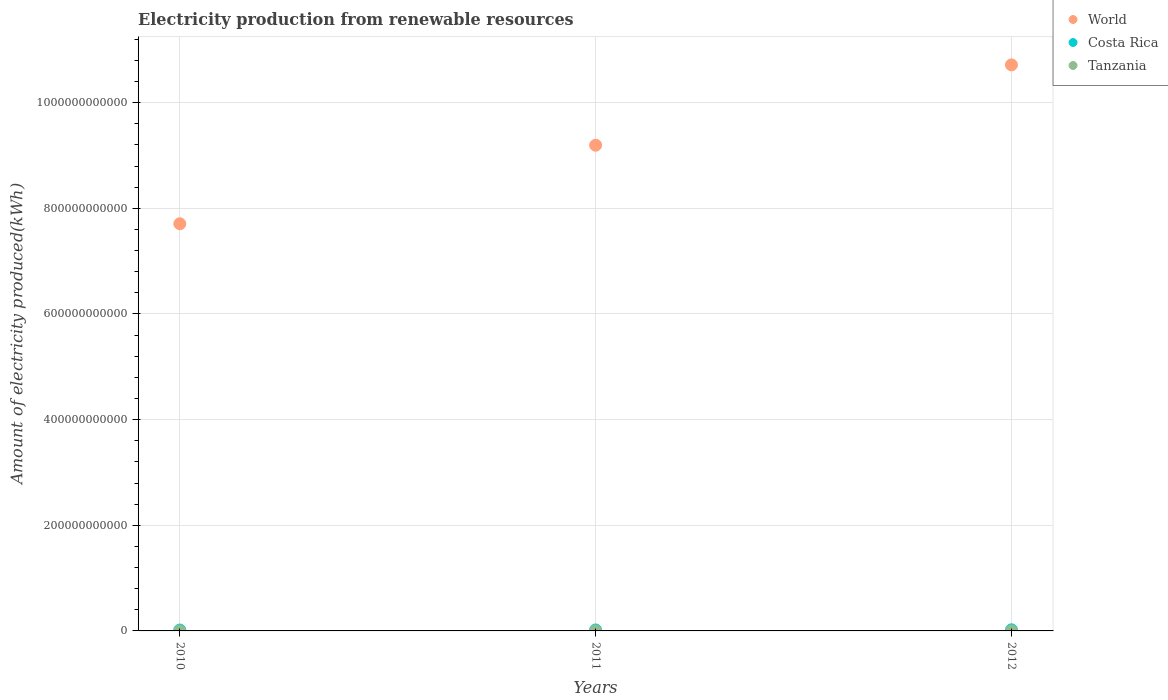How many different coloured dotlines are there?
Give a very brief answer. 3. Is the number of dotlines equal to the number of legend labels?
Give a very brief answer. Yes. What is the amount of electricity produced in World in 2012?
Keep it short and to the point. 1.07e+12. Across all years, what is the maximum amount of electricity produced in Tanzania?
Offer a very short reply. 3.20e+07. Across all years, what is the minimum amount of electricity produced in Costa Rica?
Ensure brevity in your answer.  1.68e+09. In which year was the amount of electricity produced in Costa Rica minimum?
Ensure brevity in your answer.  2010. What is the total amount of electricity produced in World in the graph?
Ensure brevity in your answer.  2.76e+12. What is the difference between the amount of electricity produced in Tanzania in 2010 and that in 2012?
Your answer should be very brief. -1.40e+07. What is the difference between the amount of electricity produced in Costa Rica in 2010 and the amount of electricity produced in World in 2012?
Provide a short and direct response. -1.07e+12. What is the average amount of electricity produced in Costa Rica per year?
Keep it short and to the point. 1.88e+09. In the year 2011, what is the difference between the amount of electricity produced in Tanzania and amount of electricity produced in Costa Rica?
Offer a very short reply. -1.81e+09. What is the ratio of the amount of electricity produced in Tanzania in 2011 to that in 2012?
Your response must be concise. 0.78. Is the amount of electricity produced in Tanzania in 2011 less than that in 2012?
Your answer should be very brief. Yes. What is the difference between the highest and the second highest amount of electricity produced in Costa Rica?
Give a very brief answer. 2.76e+08. What is the difference between the highest and the lowest amount of electricity produced in World?
Your response must be concise. 3.01e+11. Is it the case that in every year, the sum of the amount of electricity produced in World and amount of electricity produced in Costa Rica  is greater than the amount of electricity produced in Tanzania?
Keep it short and to the point. Yes. Does the amount of electricity produced in World monotonically increase over the years?
Provide a short and direct response. Yes. Is the amount of electricity produced in World strictly less than the amount of electricity produced in Costa Rica over the years?
Offer a very short reply. No. How many dotlines are there?
Your answer should be very brief. 3. How many years are there in the graph?
Offer a very short reply. 3. What is the difference between two consecutive major ticks on the Y-axis?
Provide a short and direct response. 2.00e+11. Where does the legend appear in the graph?
Your answer should be compact. Top right. How many legend labels are there?
Offer a terse response. 3. How are the legend labels stacked?
Ensure brevity in your answer.  Vertical. What is the title of the graph?
Provide a succinct answer. Electricity production from renewable resources. What is the label or title of the X-axis?
Your answer should be compact. Years. What is the label or title of the Y-axis?
Keep it short and to the point. Amount of electricity produced(kWh). What is the Amount of electricity produced(kWh) of World in 2010?
Give a very brief answer. 7.71e+11. What is the Amount of electricity produced(kWh) in Costa Rica in 2010?
Provide a short and direct response. 1.68e+09. What is the Amount of electricity produced(kWh) in Tanzania in 2010?
Your response must be concise. 1.80e+07. What is the Amount of electricity produced(kWh) in World in 2011?
Your response must be concise. 9.20e+11. What is the Amount of electricity produced(kWh) of Costa Rica in 2011?
Provide a short and direct response. 1.84e+09. What is the Amount of electricity produced(kWh) of Tanzania in 2011?
Offer a terse response. 2.50e+07. What is the Amount of electricity produced(kWh) of World in 2012?
Provide a short and direct response. 1.07e+12. What is the Amount of electricity produced(kWh) of Costa Rica in 2012?
Your response must be concise. 2.11e+09. What is the Amount of electricity produced(kWh) in Tanzania in 2012?
Offer a very short reply. 3.20e+07. Across all years, what is the maximum Amount of electricity produced(kWh) of World?
Provide a succinct answer. 1.07e+12. Across all years, what is the maximum Amount of electricity produced(kWh) of Costa Rica?
Your answer should be very brief. 2.11e+09. Across all years, what is the maximum Amount of electricity produced(kWh) in Tanzania?
Provide a succinct answer. 3.20e+07. Across all years, what is the minimum Amount of electricity produced(kWh) in World?
Offer a terse response. 7.71e+11. Across all years, what is the minimum Amount of electricity produced(kWh) in Costa Rica?
Ensure brevity in your answer.  1.68e+09. Across all years, what is the minimum Amount of electricity produced(kWh) of Tanzania?
Offer a terse response. 1.80e+07. What is the total Amount of electricity produced(kWh) in World in the graph?
Give a very brief answer. 2.76e+12. What is the total Amount of electricity produced(kWh) of Costa Rica in the graph?
Offer a very short reply. 5.63e+09. What is the total Amount of electricity produced(kWh) of Tanzania in the graph?
Make the answer very short. 7.50e+07. What is the difference between the Amount of electricity produced(kWh) of World in 2010 and that in 2011?
Offer a very short reply. -1.49e+11. What is the difference between the Amount of electricity produced(kWh) of Costa Rica in 2010 and that in 2011?
Your response must be concise. -1.55e+08. What is the difference between the Amount of electricity produced(kWh) in Tanzania in 2010 and that in 2011?
Make the answer very short. -7.00e+06. What is the difference between the Amount of electricity produced(kWh) of World in 2010 and that in 2012?
Offer a very short reply. -3.01e+11. What is the difference between the Amount of electricity produced(kWh) in Costa Rica in 2010 and that in 2012?
Keep it short and to the point. -4.31e+08. What is the difference between the Amount of electricity produced(kWh) of Tanzania in 2010 and that in 2012?
Your answer should be compact. -1.40e+07. What is the difference between the Amount of electricity produced(kWh) in World in 2011 and that in 2012?
Offer a very short reply. -1.52e+11. What is the difference between the Amount of electricity produced(kWh) of Costa Rica in 2011 and that in 2012?
Keep it short and to the point. -2.76e+08. What is the difference between the Amount of electricity produced(kWh) of Tanzania in 2011 and that in 2012?
Provide a short and direct response. -7.00e+06. What is the difference between the Amount of electricity produced(kWh) of World in 2010 and the Amount of electricity produced(kWh) of Costa Rica in 2011?
Offer a terse response. 7.69e+11. What is the difference between the Amount of electricity produced(kWh) in World in 2010 and the Amount of electricity produced(kWh) in Tanzania in 2011?
Your response must be concise. 7.71e+11. What is the difference between the Amount of electricity produced(kWh) in Costa Rica in 2010 and the Amount of electricity produced(kWh) in Tanzania in 2011?
Offer a terse response. 1.66e+09. What is the difference between the Amount of electricity produced(kWh) of World in 2010 and the Amount of electricity produced(kWh) of Costa Rica in 2012?
Provide a succinct answer. 7.69e+11. What is the difference between the Amount of electricity produced(kWh) in World in 2010 and the Amount of electricity produced(kWh) in Tanzania in 2012?
Ensure brevity in your answer.  7.71e+11. What is the difference between the Amount of electricity produced(kWh) in Costa Rica in 2010 and the Amount of electricity produced(kWh) in Tanzania in 2012?
Ensure brevity in your answer.  1.65e+09. What is the difference between the Amount of electricity produced(kWh) of World in 2011 and the Amount of electricity produced(kWh) of Costa Rica in 2012?
Your answer should be compact. 9.17e+11. What is the difference between the Amount of electricity produced(kWh) in World in 2011 and the Amount of electricity produced(kWh) in Tanzania in 2012?
Provide a short and direct response. 9.19e+11. What is the difference between the Amount of electricity produced(kWh) in Costa Rica in 2011 and the Amount of electricity produced(kWh) in Tanzania in 2012?
Make the answer very short. 1.80e+09. What is the average Amount of electricity produced(kWh) of World per year?
Provide a short and direct response. 9.21e+11. What is the average Amount of electricity produced(kWh) of Costa Rica per year?
Provide a succinct answer. 1.88e+09. What is the average Amount of electricity produced(kWh) in Tanzania per year?
Your answer should be very brief. 2.50e+07. In the year 2010, what is the difference between the Amount of electricity produced(kWh) in World and Amount of electricity produced(kWh) in Costa Rica?
Offer a very short reply. 7.69e+11. In the year 2010, what is the difference between the Amount of electricity produced(kWh) in World and Amount of electricity produced(kWh) in Tanzania?
Give a very brief answer. 7.71e+11. In the year 2010, what is the difference between the Amount of electricity produced(kWh) of Costa Rica and Amount of electricity produced(kWh) of Tanzania?
Offer a very short reply. 1.66e+09. In the year 2011, what is the difference between the Amount of electricity produced(kWh) in World and Amount of electricity produced(kWh) in Costa Rica?
Your answer should be compact. 9.18e+11. In the year 2011, what is the difference between the Amount of electricity produced(kWh) of World and Amount of electricity produced(kWh) of Tanzania?
Offer a terse response. 9.19e+11. In the year 2011, what is the difference between the Amount of electricity produced(kWh) of Costa Rica and Amount of electricity produced(kWh) of Tanzania?
Offer a very short reply. 1.81e+09. In the year 2012, what is the difference between the Amount of electricity produced(kWh) of World and Amount of electricity produced(kWh) of Costa Rica?
Provide a short and direct response. 1.07e+12. In the year 2012, what is the difference between the Amount of electricity produced(kWh) of World and Amount of electricity produced(kWh) of Tanzania?
Your answer should be compact. 1.07e+12. In the year 2012, what is the difference between the Amount of electricity produced(kWh) of Costa Rica and Amount of electricity produced(kWh) of Tanzania?
Make the answer very short. 2.08e+09. What is the ratio of the Amount of electricity produced(kWh) in World in 2010 to that in 2011?
Provide a succinct answer. 0.84. What is the ratio of the Amount of electricity produced(kWh) in Costa Rica in 2010 to that in 2011?
Make the answer very short. 0.92. What is the ratio of the Amount of electricity produced(kWh) of Tanzania in 2010 to that in 2011?
Make the answer very short. 0.72. What is the ratio of the Amount of electricity produced(kWh) of World in 2010 to that in 2012?
Offer a very short reply. 0.72. What is the ratio of the Amount of electricity produced(kWh) of Costa Rica in 2010 to that in 2012?
Keep it short and to the point. 0.8. What is the ratio of the Amount of electricity produced(kWh) of Tanzania in 2010 to that in 2012?
Offer a terse response. 0.56. What is the ratio of the Amount of electricity produced(kWh) in World in 2011 to that in 2012?
Make the answer very short. 0.86. What is the ratio of the Amount of electricity produced(kWh) of Costa Rica in 2011 to that in 2012?
Provide a short and direct response. 0.87. What is the ratio of the Amount of electricity produced(kWh) in Tanzania in 2011 to that in 2012?
Your answer should be compact. 0.78. What is the difference between the highest and the second highest Amount of electricity produced(kWh) of World?
Provide a short and direct response. 1.52e+11. What is the difference between the highest and the second highest Amount of electricity produced(kWh) of Costa Rica?
Keep it short and to the point. 2.76e+08. What is the difference between the highest and the lowest Amount of electricity produced(kWh) in World?
Provide a succinct answer. 3.01e+11. What is the difference between the highest and the lowest Amount of electricity produced(kWh) of Costa Rica?
Provide a succinct answer. 4.31e+08. What is the difference between the highest and the lowest Amount of electricity produced(kWh) of Tanzania?
Make the answer very short. 1.40e+07. 